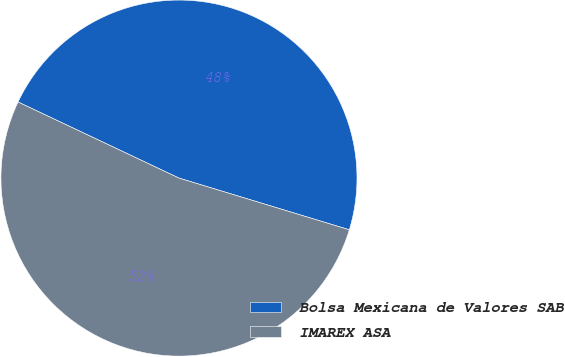<chart> <loc_0><loc_0><loc_500><loc_500><pie_chart><fcel>Bolsa Mexicana de Valores SAB<fcel>IMAREX ASA<nl><fcel>47.66%<fcel>52.34%<nl></chart> 